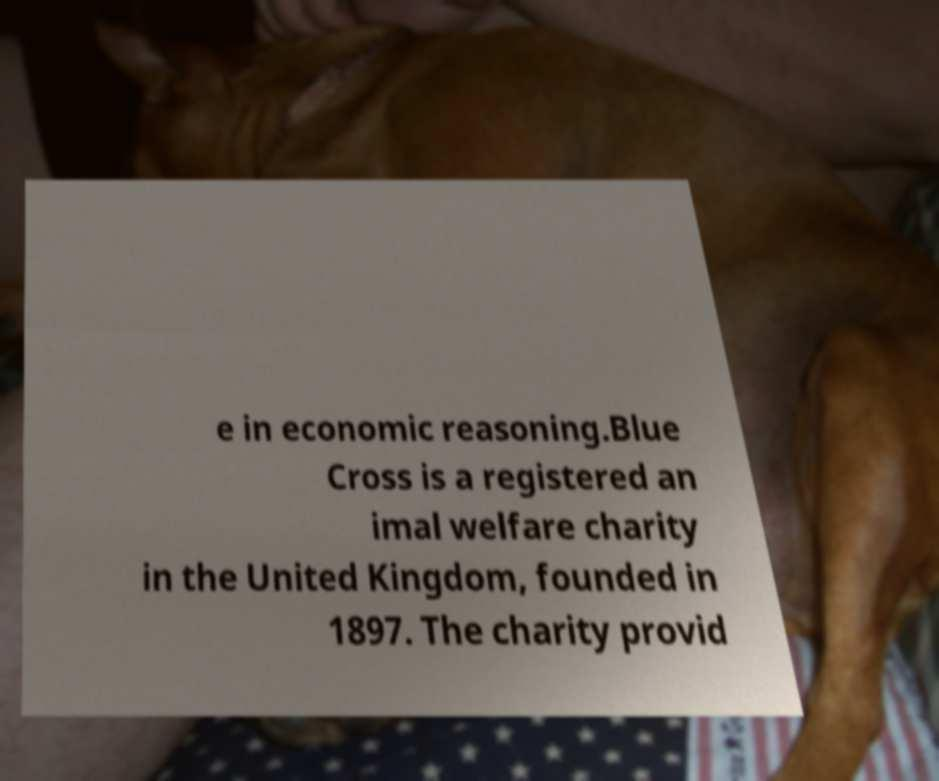I need the written content from this picture converted into text. Can you do that? e in economic reasoning.Blue Cross is a registered an imal welfare charity in the United Kingdom, founded in 1897. The charity provid 